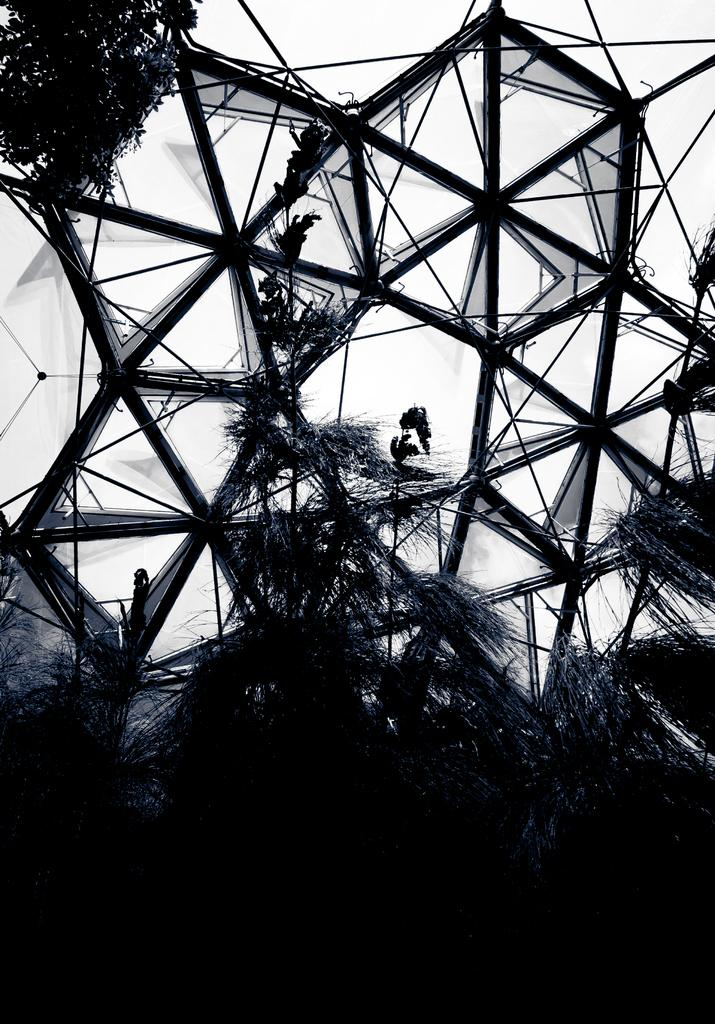What type of vegetation can be seen in the image? There are trees and plants in the image. What else is present in the image besides vegetation? There is a building structure in the image. Where is the rake being used to clean up leaves in the image? There is no rake present in the image, so it cannot be used to clean up leaves. 